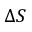<formula> <loc_0><loc_0><loc_500><loc_500>\Delta S</formula> 